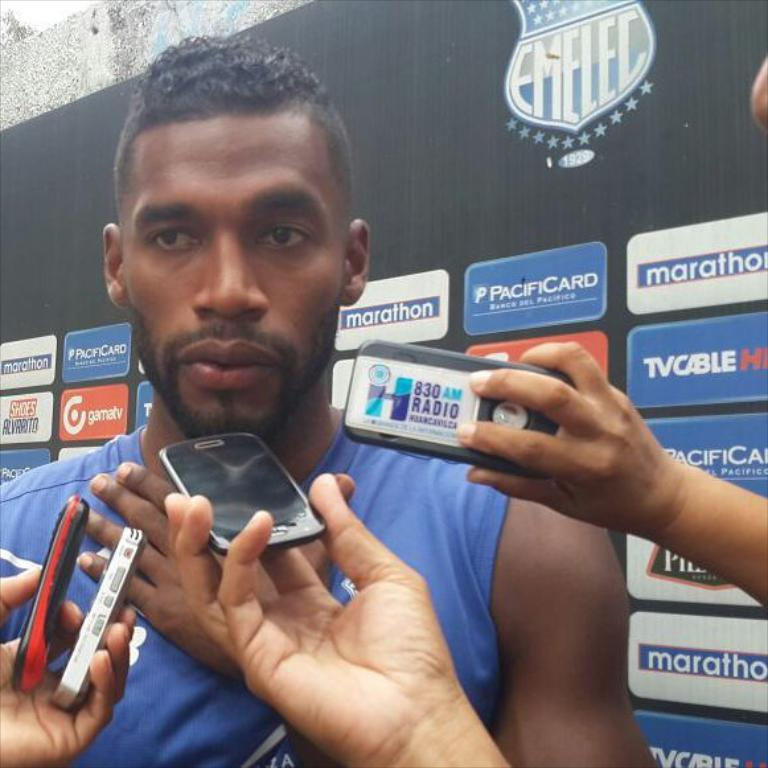What is the main subject of the image? There is a person standing in the image. What is located behind the person? There is a banner behind the person. What are some people in the image doing? There are people holding mobiles in the image. What type of art is the person's uncle creating in the image? There is no mention of an uncle or any art in the image, so we cannot answer this question. 